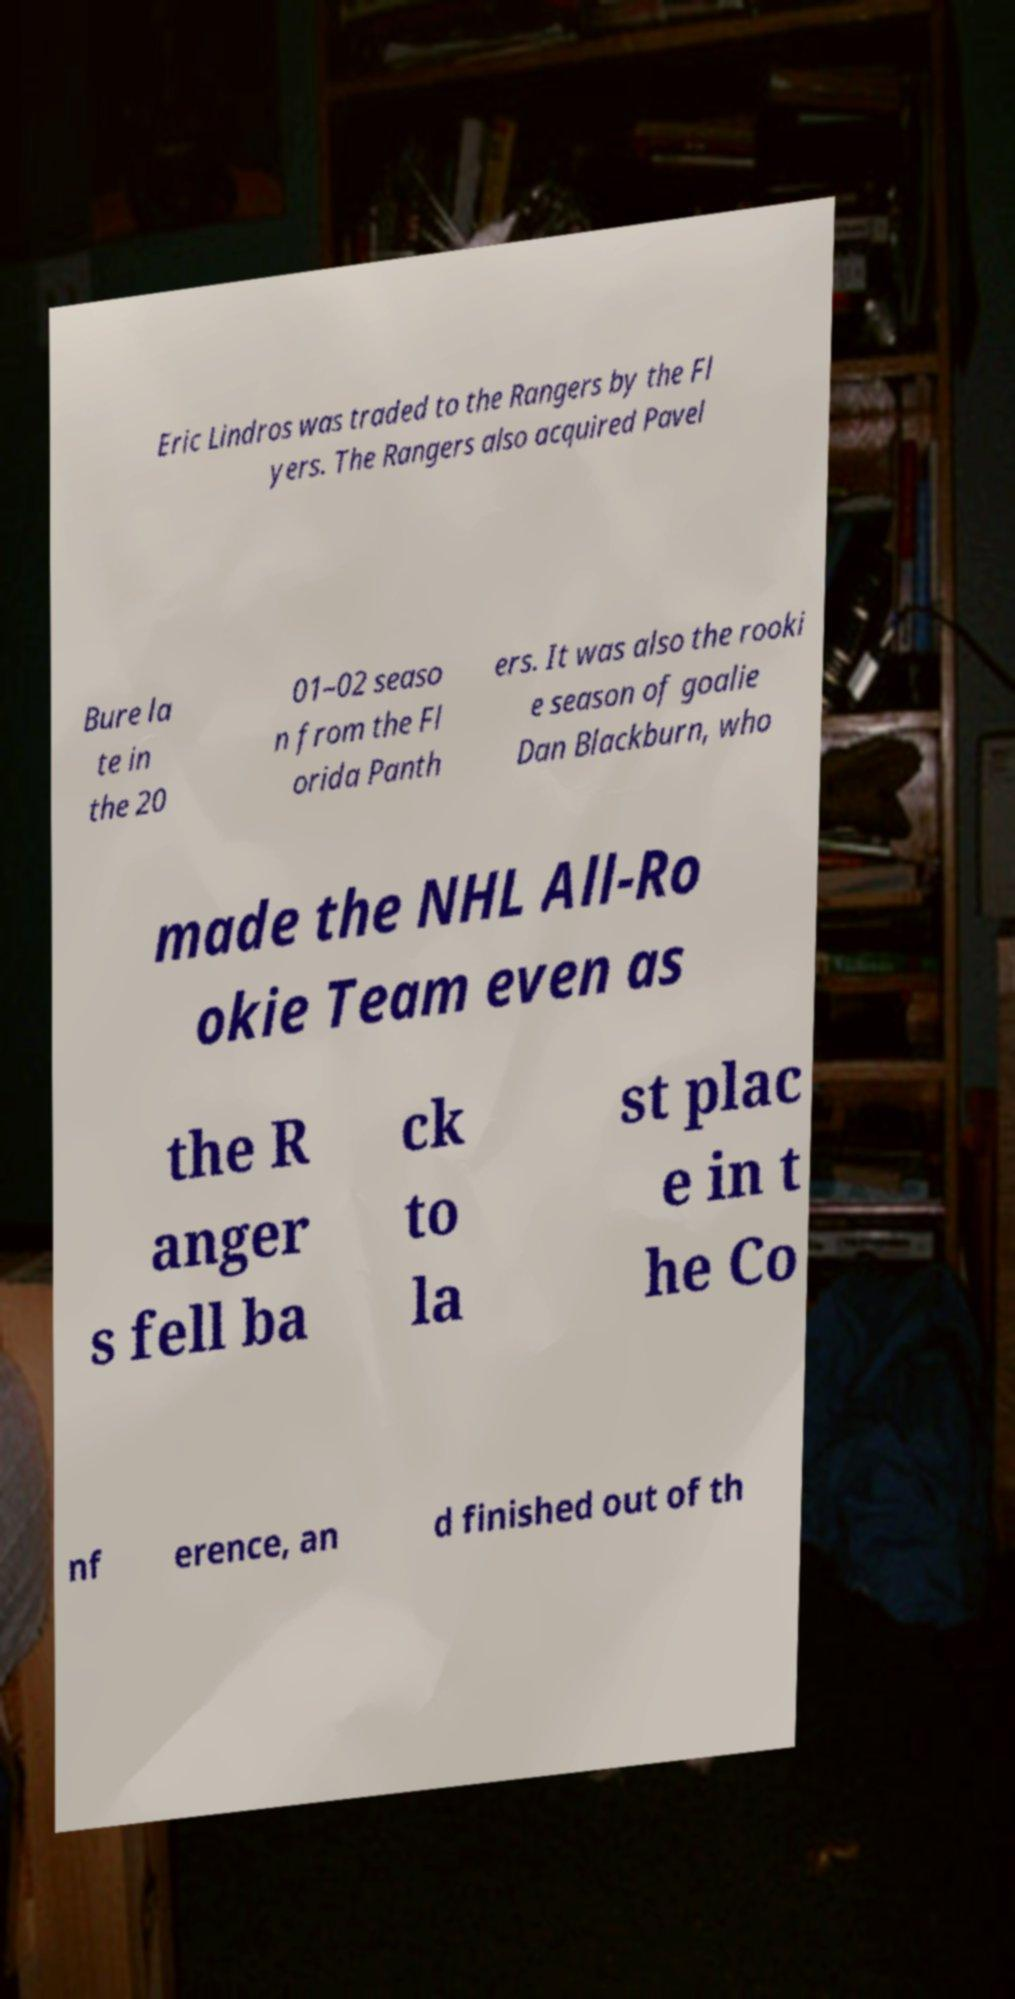Can you read and provide the text displayed in the image?This photo seems to have some interesting text. Can you extract and type it out for me? Eric Lindros was traded to the Rangers by the Fl yers. The Rangers also acquired Pavel Bure la te in the 20 01–02 seaso n from the Fl orida Panth ers. It was also the rooki e season of goalie Dan Blackburn, who made the NHL All-Ro okie Team even as the R anger s fell ba ck to la st plac e in t he Co nf erence, an d finished out of th 